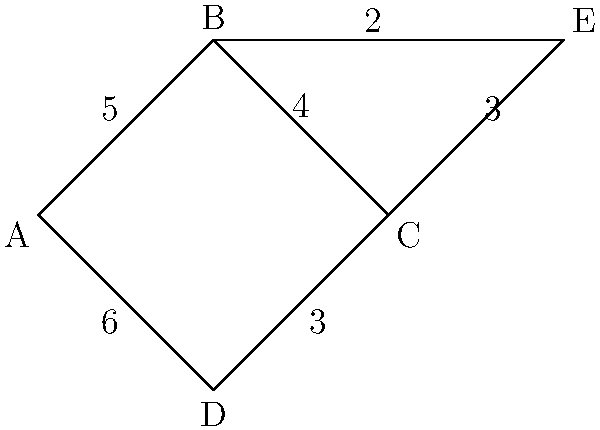As a railway worker concerned with passenger safety and comfort, you need to determine the shortest route between stations A and C on this network diagram. What is the length of the shortest path from A to C? To find the shortest path from A to C, we need to consider all possible routes and calculate their total distances:

1. Path A-B-C:
   A to B = 5
   B to C = 4
   Total = 5 + 4 = 9

2. Path A-D-C:
   A to D = 6
   D to C = 3
   Total = 6 + 3 = 9

3. Path A-B-E-C:
   A to B = 5
   B to E = 2
   E to C = 3
   Total = 5 + 2 + 3 = 10

The shortest paths are A-B-C and A-D-C, both with a total distance of 9.

As a railway worker with empathy for passengers, it's important to note that while both routes have the same distance, factors such as train frequency, station accessibility, and potential delays should also be considered when advising passengers on the best route.
Answer: 9 